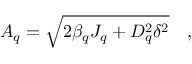<formula> <loc_0><loc_0><loc_500><loc_500>A _ { q } = \sqrt { 2 \beta _ { q } J _ { q } + D _ { q } ^ { 2 } \delta ^ { 2 } } \quad ,</formula> 